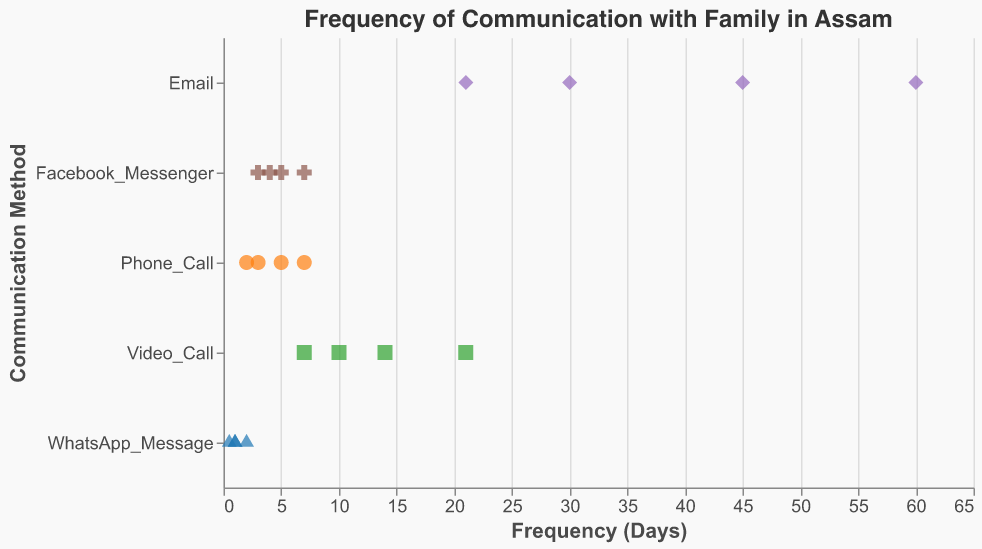What is the title of the plot? The title is prominently displayed at the top of the plot and is written in a larger font to provide context about the figure.
Answer: Frequency of Communication with Family in Assam What communication method has the maximum frequency period? Look at the plot and identify the method that has the data point furthest to the right on the x-axis, representing the number of days.
Answer: Email How often do you use WhatsApp Messages to communicate with family on average? Find the data points for WhatsApp Messages, sum their frequencies, and divide by the number of data points. The values are 1, 0.5, 2, and 1. (1 + 0.5 + 2 + 1)/4 = 1.125
Answer: 1.125 days Which communication method has the narrowest range of frequencies? Examine the spread of data points along the x-axis for each communication method and determine which one has the smallest range (difference between the largest and smallest values).
Answer: WhatsApp_Message What is the shortest frequency of communication for Phone Calls? Identify the Phone Call data points and find the minimum value among them, which represents the shortest frequency of communication.
Answer: 2 days How does the frequency of Email communication compare to Facebook Messenger communication? Compare the data points for Email and Facebook Messenger to see which method has a higher range of frequency values for communication.
Answer: Email has a higher frequency range How many days are between the most frequent and least frequent video calls? Find the video call data points, identify the maximum and minimum values, and calculate the difference. The values are 14, 10, 21, and 7. The difference is 21 - 7 = 14 days.
Answer: 14 days Which communication method has the highest variability in days? Evaluate the spread of data points for each communication method and identify the one with the widest distribution along the x-axis.
Answer: Email What is the median frequency for Facebook Messenger? Identify the data points for Facebook Messenger: 5, 3, 7, and 4. Arrange them in order (3, 4, 5, 7) and find the median value. Since there are four data points, the median is the average of the two middle values: (4 + 5)/2 = 4.5 days.
Answer: 4.5 days 